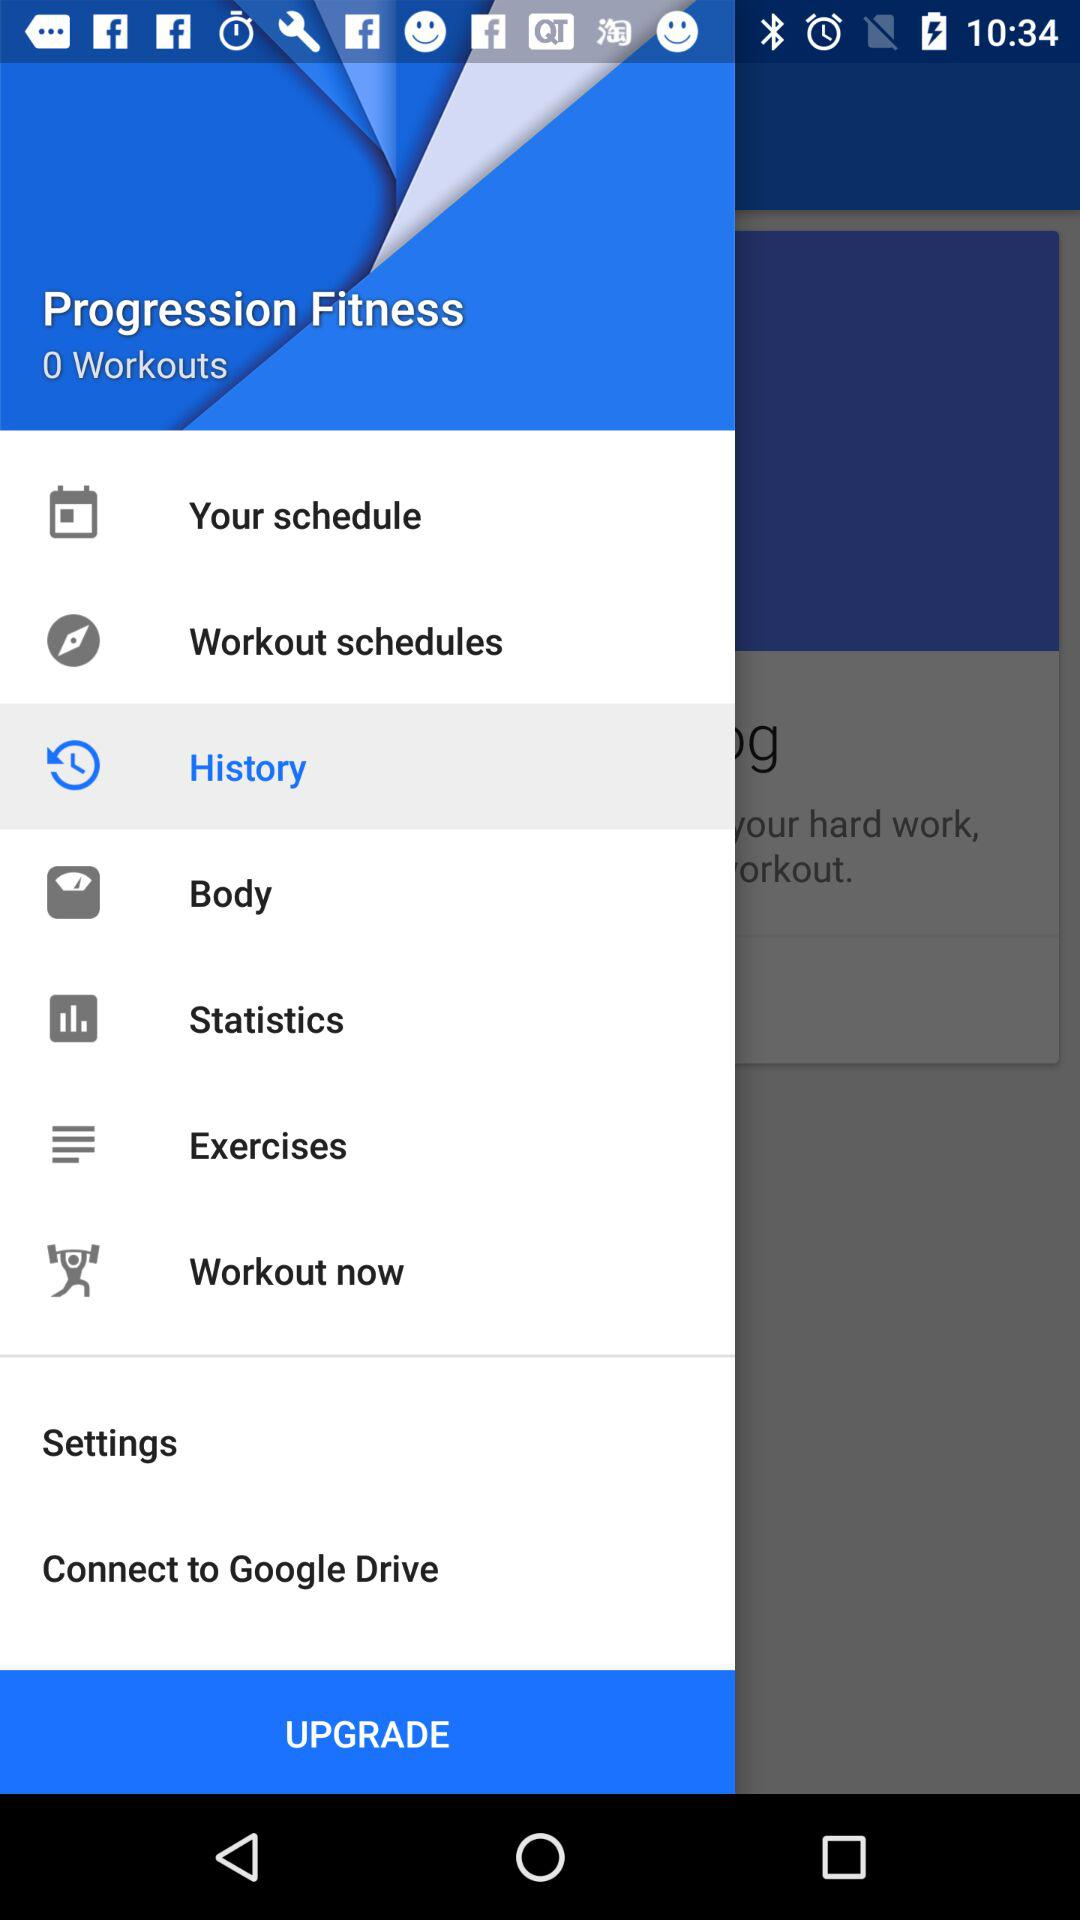What is the number of workouts? The number of workout is 0. 